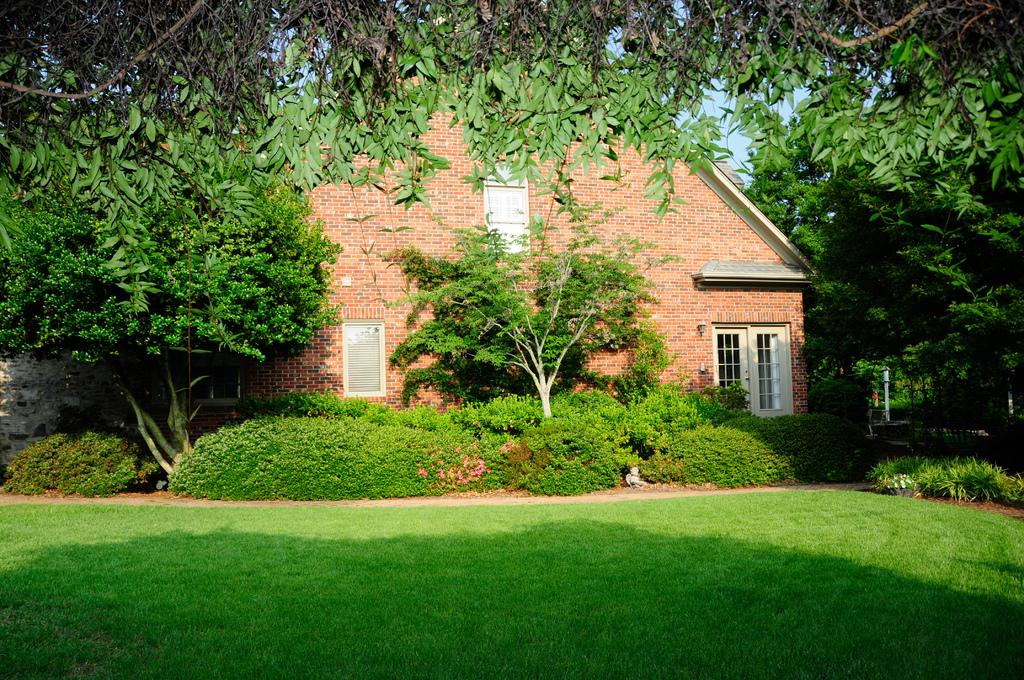What is the main subject in the center of the image? There is a house in the center of the image. What can be seen in the background of the image? There are trees and plants in the background of the image. What type of vegetation is at the bottom of the image? There is grass at the bottom of the image. What type of horse can be seen near the hydrant in the image? There is no horse or hydrant present in the image. What is the texture of the grass in the image? The texture of the grass cannot be determined from the image alone, as it is a 2D representation. 